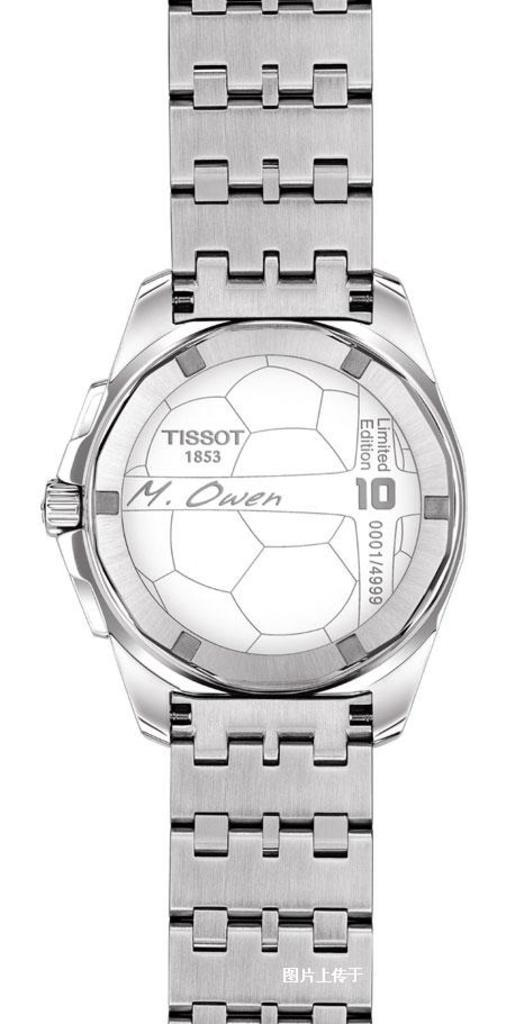<image>
Render a clear and concise summary of the photo. A Tissot watch doesn't have any hands on it. 